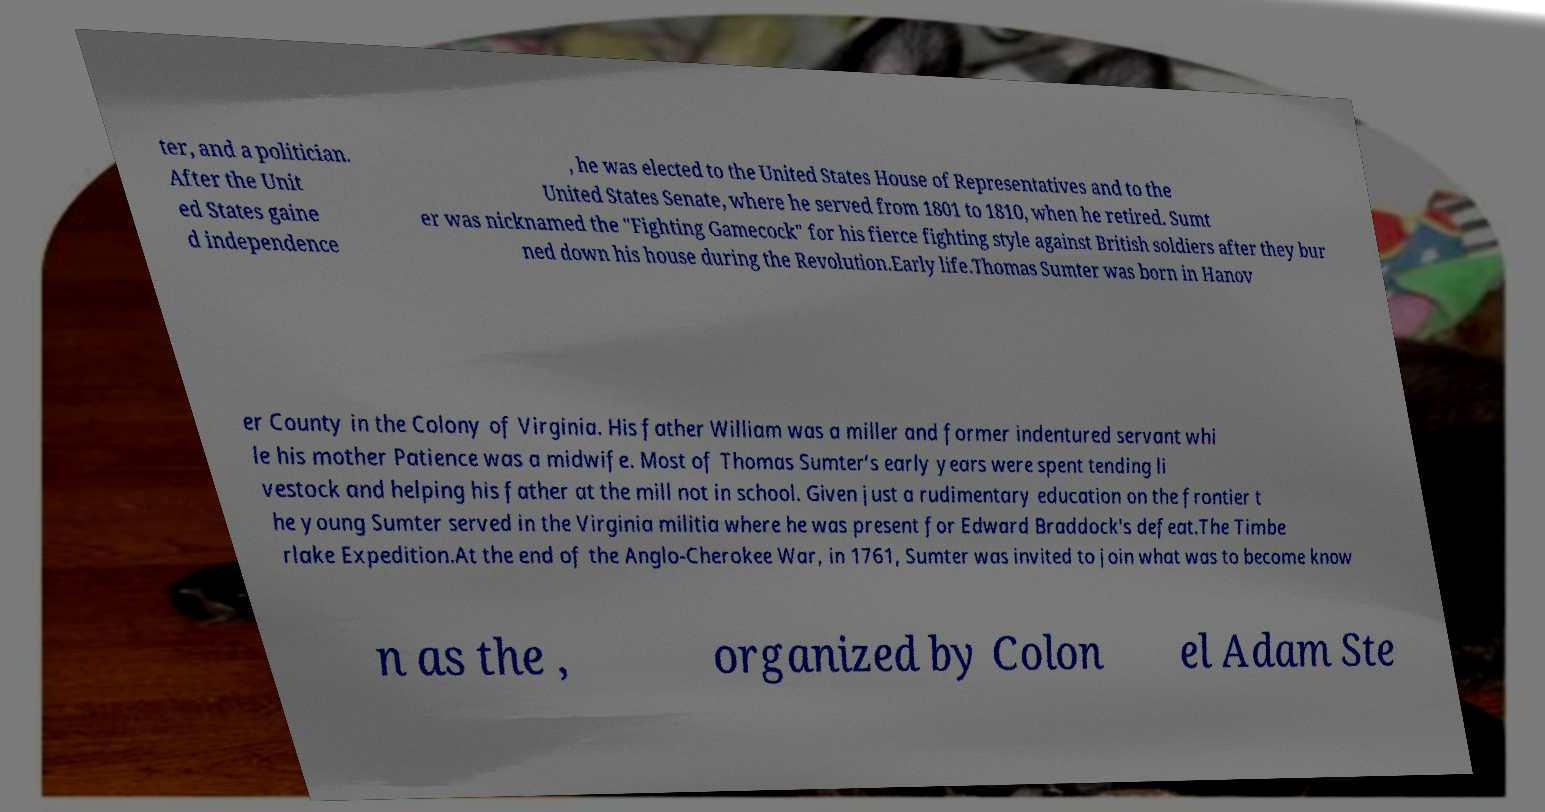Can you accurately transcribe the text from the provided image for me? ter, and a politician. After the Unit ed States gaine d independence , he was elected to the United States House of Representatives and to the United States Senate, where he served from 1801 to 1810, when he retired. Sumt er was nicknamed the "Fighting Gamecock" for his fierce fighting style against British soldiers after they bur ned down his house during the Revolution.Early life.Thomas Sumter was born in Hanov er County in the Colony of Virginia. His father William was a miller and former indentured servant whi le his mother Patience was a midwife. Most of Thomas Sumter’s early years were spent tending li vestock and helping his father at the mill not in school. Given just a rudimentary education on the frontier t he young Sumter served in the Virginia militia where he was present for Edward Braddock's defeat.The Timbe rlake Expedition.At the end of the Anglo-Cherokee War, in 1761, Sumter was invited to join what was to become know n as the , organized by Colon el Adam Ste 